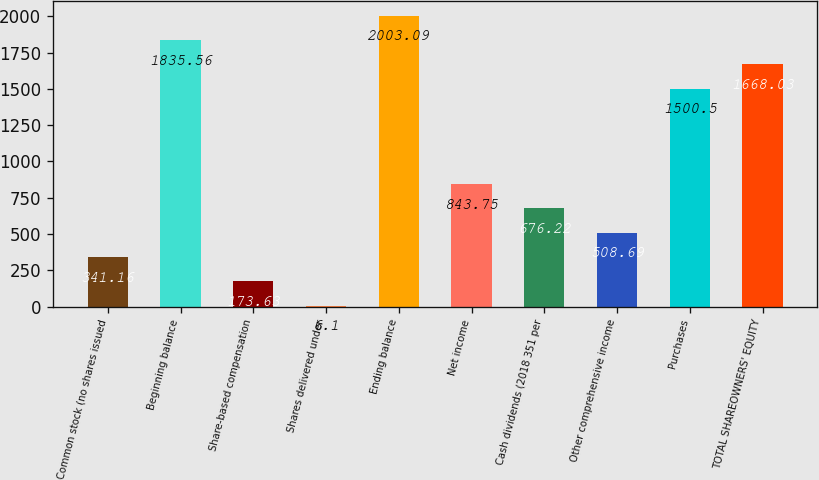<chart> <loc_0><loc_0><loc_500><loc_500><bar_chart><fcel>Common stock (no shares issued<fcel>Beginning balance<fcel>Share-based compensation<fcel>Shares delivered under<fcel>Ending balance<fcel>Net income<fcel>Cash dividends (2018 351 per<fcel>Other comprehensive income<fcel>Purchases<fcel>TOTAL SHAREOWNERS' EQUITY<nl><fcel>341.16<fcel>1835.56<fcel>173.63<fcel>6.1<fcel>2003.09<fcel>843.75<fcel>676.22<fcel>508.69<fcel>1500.5<fcel>1668.03<nl></chart> 